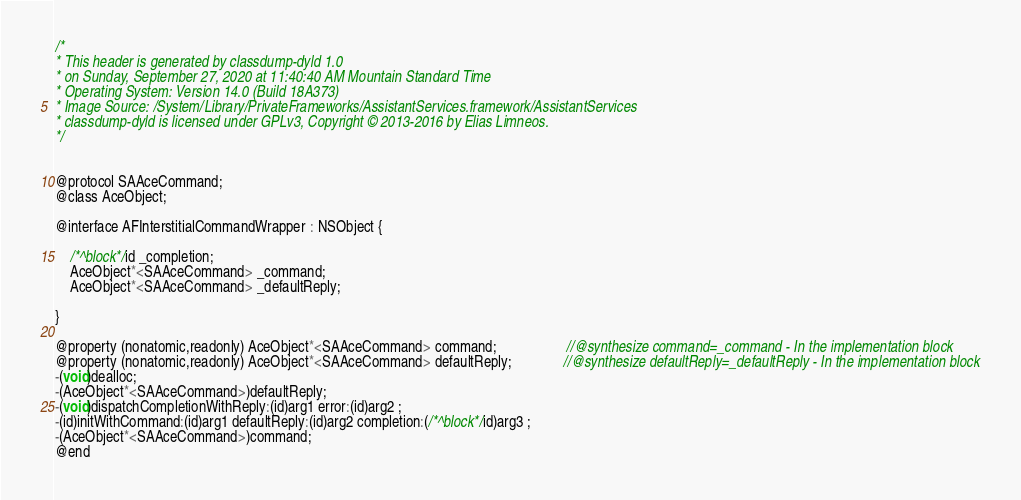Convert code to text. <code><loc_0><loc_0><loc_500><loc_500><_C_>/*
* This header is generated by classdump-dyld 1.0
* on Sunday, September 27, 2020 at 11:40:40 AM Mountain Standard Time
* Operating System: Version 14.0 (Build 18A373)
* Image Source: /System/Library/PrivateFrameworks/AssistantServices.framework/AssistantServices
* classdump-dyld is licensed under GPLv3, Copyright © 2013-2016 by Elias Limneos.
*/


@protocol SAAceCommand;
@class AceObject;

@interface AFInterstitialCommandWrapper : NSObject {

	/*^block*/id _completion;
	AceObject*<SAAceCommand> _command;
	AceObject*<SAAceCommand> _defaultReply;

}

@property (nonatomic,readonly) AceObject*<SAAceCommand> command;                   //@synthesize command=_command - In the implementation block
@property (nonatomic,readonly) AceObject*<SAAceCommand> defaultReply;              //@synthesize defaultReply=_defaultReply - In the implementation block
-(void)dealloc;
-(AceObject*<SAAceCommand>)defaultReply;
-(void)dispatchCompletionWithReply:(id)arg1 error:(id)arg2 ;
-(id)initWithCommand:(id)arg1 defaultReply:(id)arg2 completion:(/*^block*/id)arg3 ;
-(AceObject*<SAAceCommand>)command;
@end

</code> 